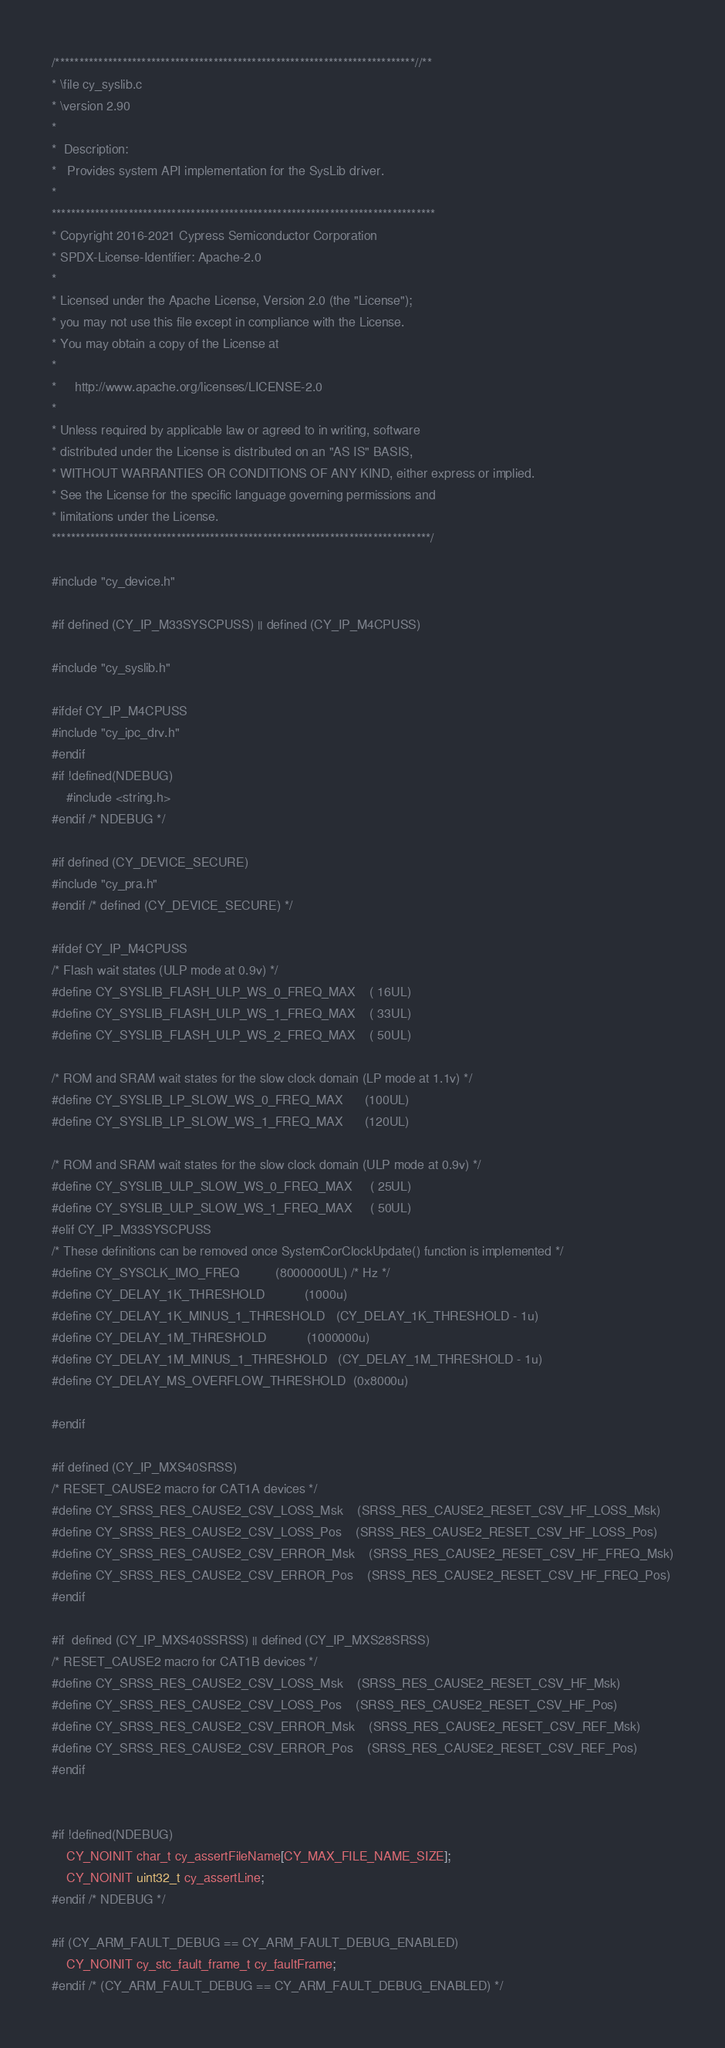Convert code to text. <code><loc_0><loc_0><loc_500><loc_500><_C_>/***************************************************************************//**
* \file cy_syslib.c
* \version 2.90
*
*  Description:
*   Provides system API implementation for the SysLib driver.
*
********************************************************************************
* Copyright 2016-2021 Cypress Semiconductor Corporation
* SPDX-License-Identifier: Apache-2.0
*
* Licensed under the Apache License, Version 2.0 (the "License");
* you may not use this file except in compliance with the License.
* You may obtain a copy of the License at
*
*     http://www.apache.org/licenses/LICENSE-2.0
*
* Unless required by applicable law or agreed to in writing, software
* distributed under the License is distributed on an "AS IS" BASIS,
* WITHOUT WARRANTIES OR CONDITIONS OF ANY KIND, either express or implied.
* See the License for the specific language governing permissions and
* limitations under the License.
*******************************************************************************/

#include "cy_device.h"

#if defined (CY_IP_M33SYSCPUSS) || defined (CY_IP_M4CPUSS)

#include "cy_syslib.h"

#ifdef CY_IP_M4CPUSS
#include "cy_ipc_drv.h"
#endif
#if !defined(NDEBUG)
    #include <string.h>
#endif /* NDEBUG */

#if defined (CY_DEVICE_SECURE)
#include "cy_pra.h"
#endif /* defined (CY_DEVICE_SECURE) */

#ifdef CY_IP_M4CPUSS
/* Flash wait states (ULP mode at 0.9v) */
#define CY_SYSLIB_FLASH_ULP_WS_0_FREQ_MAX    ( 16UL)
#define CY_SYSLIB_FLASH_ULP_WS_1_FREQ_MAX    ( 33UL)
#define CY_SYSLIB_FLASH_ULP_WS_2_FREQ_MAX    ( 50UL)

/* ROM and SRAM wait states for the slow clock domain (LP mode at 1.1v) */
#define CY_SYSLIB_LP_SLOW_WS_0_FREQ_MAX      (100UL)
#define CY_SYSLIB_LP_SLOW_WS_1_FREQ_MAX      (120UL)

/* ROM and SRAM wait states for the slow clock domain (ULP mode at 0.9v) */
#define CY_SYSLIB_ULP_SLOW_WS_0_FREQ_MAX     ( 25UL)
#define CY_SYSLIB_ULP_SLOW_WS_1_FREQ_MAX     ( 50UL)
#elif CY_IP_M33SYSCPUSS
/* These definitions can be removed once SystemCorClockUpdate() function is implemented */
#define CY_SYSCLK_IMO_FREQ          (8000000UL) /* Hz */
#define CY_DELAY_1K_THRESHOLD           (1000u)
#define CY_DELAY_1K_MINUS_1_THRESHOLD   (CY_DELAY_1K_THRESHOLD - 1u)
#define CY_DELAY_1M_THRESHOLD           (1000000u)
#define CY_DELAY_1M_MINUS_1_THRESHOLD   (CY_DELAY_1M_THRESHOLD - 1u)
#define CY_DELAY_MS_OVERFLOW_THRESHOLD  (0x8000u)

#endif

#if defined (CY_IP_MXS40SRSS)
/* RESET_CAUSE2 macro for CAT1A devices */
#define CY_SRSS_RES_CAUSE2_CSV_LOSS_Msk    (SRSS_RES_CAUSE2_RESET_CSV_HF_LOSS_Msk)
#define CY_SRSS_RES_CAUSE2_CSV_LOSS_Pos    (SRSS_RES_CAUSE2_RESET_CSV_HF_LOSS_Pos)
#define CY_SRSS_RES_CAUSE2_CSV_ERROR_Msk    (SRSS_RES_CAUSE2_RESET_CSV_HF_FREQ_Msk)
#define CY_SRSS_RES_CAUSE2_CSV_ERROR_Pos    (SRSS_RES_CAUSE2_RESET_CSV_HF_FREQ_Pos)
#endif

#if  defined (CY_IP_MXS40SSRSS) || defined (CY_IP_MXS28SRSS)
/* RESET_CAUSE2 macro for CAT1B devices */
#define CY_SRSS_RES_CAUSE2_CSV_LOSS_Msk    (SRSS_RES_CAUSE2_RESET_CSV_HF_Msk)
#define CY_SRSS_RES_CAUSE2_CSV_LOSS_Pos    (SRSS_RES_CAUSE2_RESET_CSV_HF_Pos)
#define CY_SRSS_RES_CAUSE2_CSV_ERROR_Msk    (SRSS_RES_CAUSE2_RESET_CSV_REF_Msk)
#define CY_SRSS_RES_CAUSE2_CSV_ERROR_Pos    (SRSS_RES_CAUSE2_RESET_CSV_REF_Pos)
#endif


#if !defined(NDEBUG)
    CY_NOINIT char_t cy_assertFileName[CY_MAX_FILE_NAME_SIZE];
    CY_NOINIT uint32_t cy_assertLine;
#endif /* NDEBUG */

#if (CY_ARM_FAULT_DEBUG == CY_ARM_FAULT_DEBUG_ENABLED)
    CY_NOINIT cy_stc_fault_frame_t cy_faultFrame;
#endif /* (CY_ARM_FAULT_DEBUG == CY_ARM_FAULT_DEBUG_ENABLED) */
</code> 